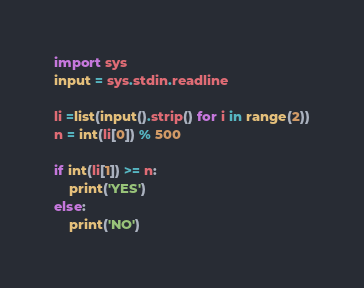<code> <loc_0><loc_0><loc_500><loc_500><_Python_>import sys
input = sys.stdin.readline

li =list(input().strip() for i in range(2))
n = int(li[0]) % 500

if int(li[1]) >= n:
    print('YES')
else:
    print('NO')
</code> 